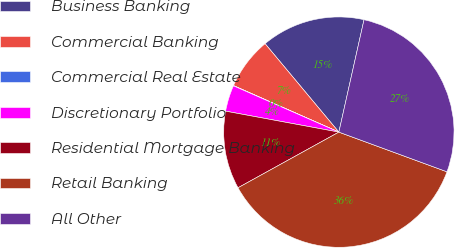<chart> <loc_0><loc_0><loc_500><loc_500><pie_chart><fcel>Business Banking<fcel>Commercial Banking<fcel>Commercial Real Estate<fcel>Discretionary Portfolio<fcel>Residential Mortgage Banking<fcel>Retail Banking<fcel>All Other<nl><fcel>14.57%<fcel>7.31%<fcel>0.04%<fcel>3.67%<fcel>10.94%<fcel>36.37%<fcel>27.09%<nl></chart> 